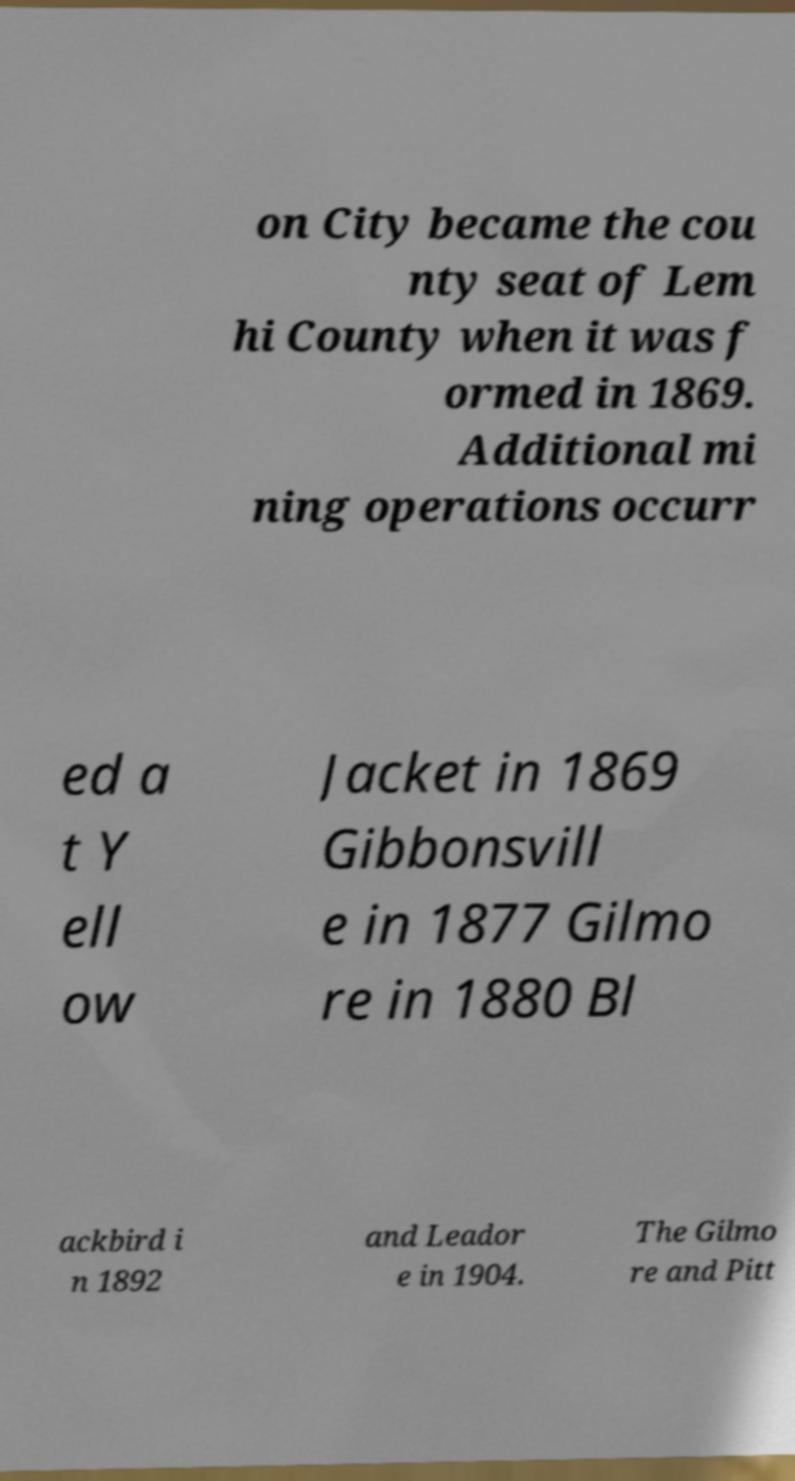Can you read and provide the text displayed in the image?This photo seems to have some interesting text. Can you extract and type it out for me? on City became the cou nty seat of Lem hi County when it was f ormed in 1869. Additional mi ning operations occurr ed a t Y ell ow Jacket in 1869 Gibbonsvill e in 1877 Gilmo re in 1880 Bl ackbird i n 1892 and Leador e in 1904. The Gilmo re and Pitt 